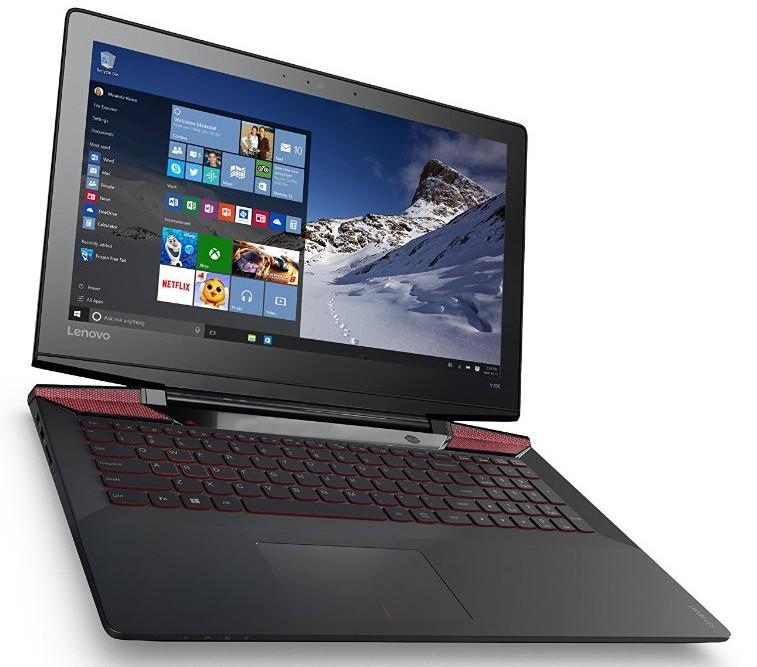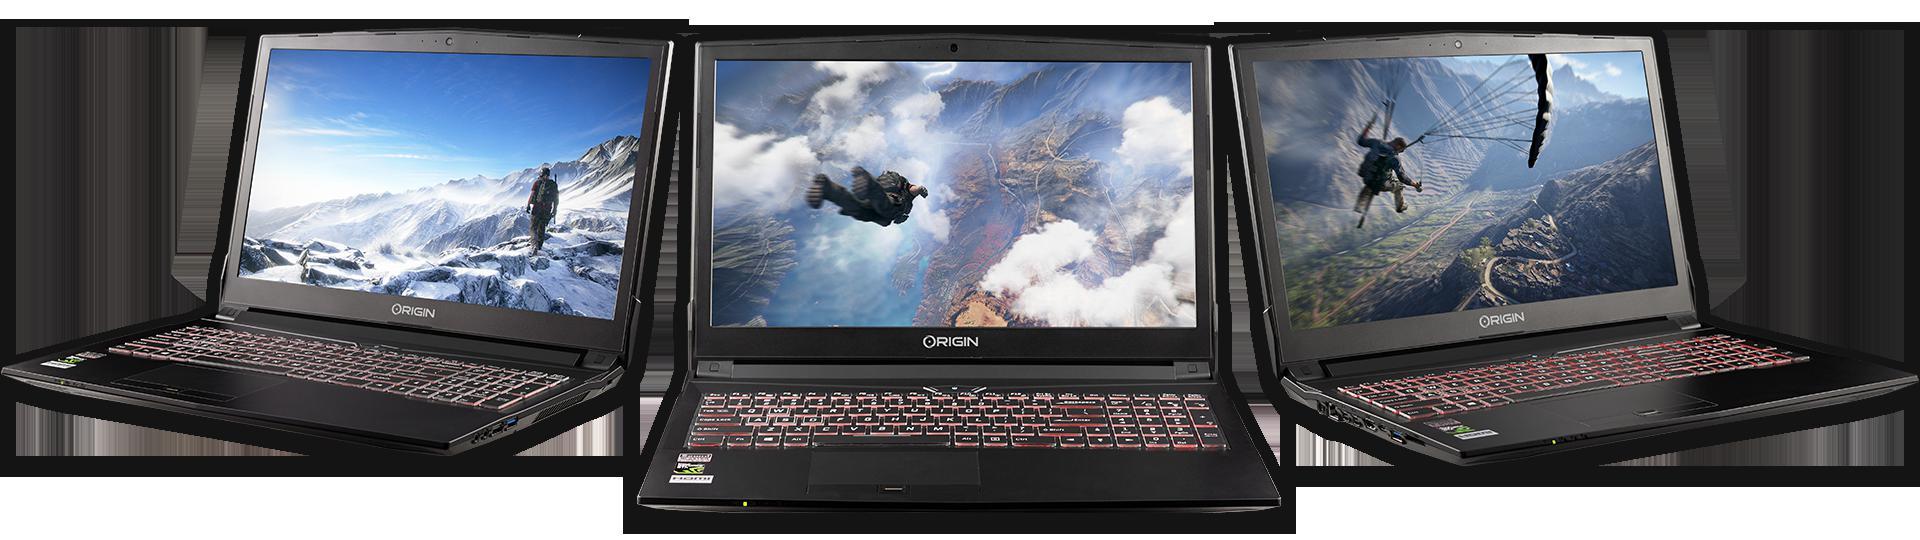The first image is the image on the left, the second image is the image on the right. Given the left and right images, does the statement "Three open laptops with imagery on the screens are displayed horizontally in one picture." hold true? Answer yes or no. Yes. The first image is the image on the left, the second image is the image on the right. Examine the images to the left and right. Is the description "There are three grouped laptops in the image on the right." accurate? Answer yes or no. Yes. 